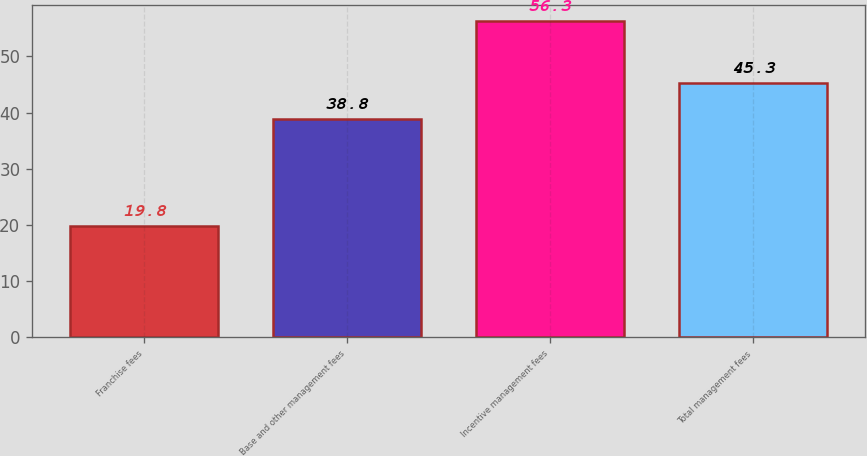Convert chart to OTSL. <chart><loc_0><loc_0><loc_500><loc_500><bar_chart><fcel>Franchise fees<fcel>Base and other management fees<fcel>Incentive management fees<fcel>Total management fees<nl><fcel>19.8<fcel>38.8<fcel>56.3<fcel>45.3<nl></chart> 